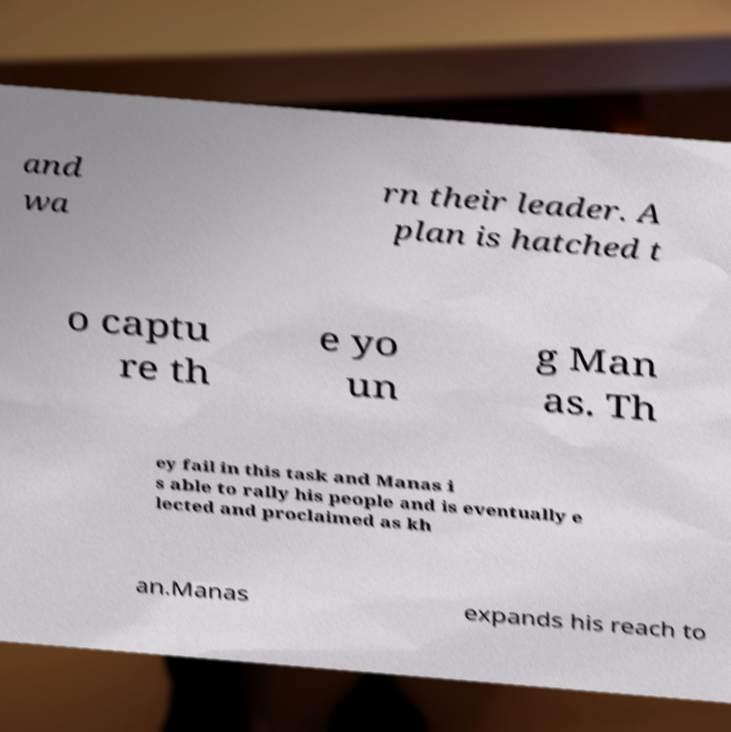I need the written content from this picture converted into text. Can you do that? and wa rn their leader. A plan is hatched t o captu re th e yo un g Man as. Th ey fail in this task and Manas i s able to rally his people and is eventually e lected and proclaimed as kh an.Manas expands his reach to 